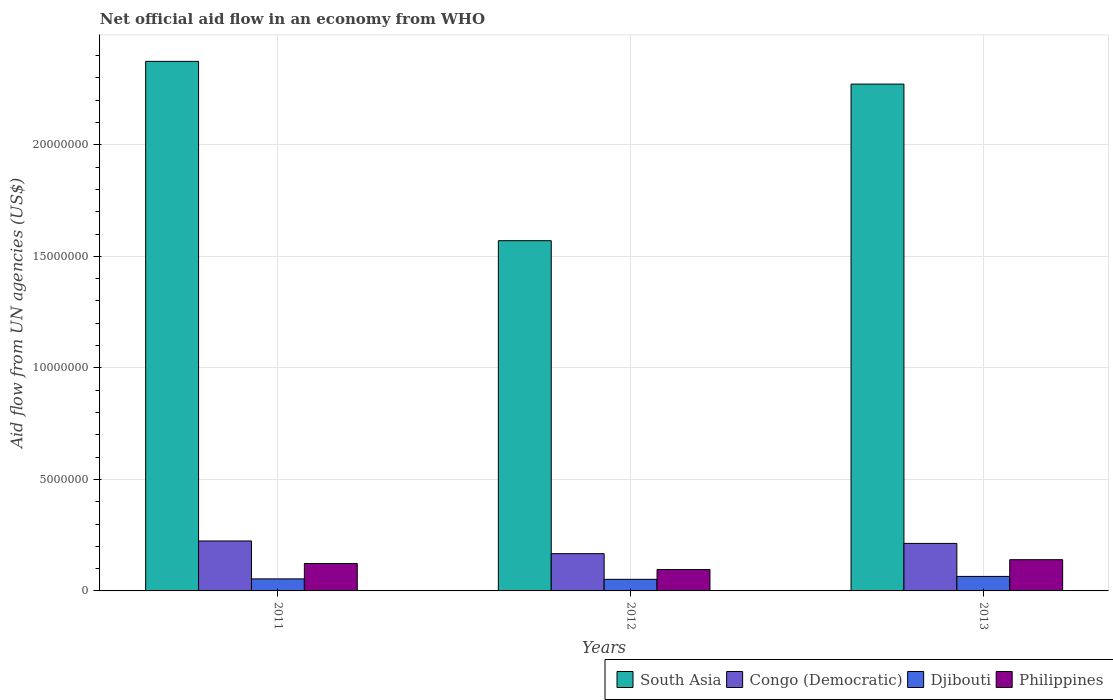How many different coloured bars are there?
Keep it short and to the point. 4. How many groups of bars are there?
Make the answer very short. 3. Are the number of bars on each tick of the X-axis equal?
Your answer should be compact. Yes. How many bars are there on the 2nd tick from the left?
Give a very brief answer. 4. How many bars are there on the 2nd tick from the right?
Keep it short and to the point. 4. In how many cases, is the number of bars for a given year not equal to the number of legend labels?
Your answer should be very brief. 0. What is the net official aid flow in South Asia in 2011?
Your answer should be compact. 2.37e+07. Across all years, what is the maximum net official aid flow in Philippines?
Offer a terse response. 1.40e+06. Across all years, what is the minimum net official aid flow in South Asia?
Your answer should be compact. 1.57e+07. What is the total net official aid flow in South Asia in the graph?
Provide a short and direct response. 6.22e+07. What is the difference between the net official aid flow in South Asia in 2011 and that in 2013?
Your answer should be compact. 1.02e+06. What is the difference between the net official aid flow in Djibouti in 2011 and the net official aid flow in South Asia in 2013?
Your response must be concise. -2.22e+07. What is the average net official aid flow in Philippines per year?
Your answer should be compact. 1.20e+06. In the year 2013, what is the difference between the net official aid flow in Philippines and net official aid flow in Congo (Democratic)?
Ensure brevity in your answer.  -7.30e+05. What is the ratio of the net official aid flow in Djibouti in 2011 to that in 2013?
Offer a very short reply. 0.83. Is the net official aid flow in Congo (Democratic) in 2012 less than that in 2013?
Make the answer very short. Yes. What is the difference between the highest and the lowest net official aid flow in South Asia?
Your answer should be compact. 8.04e+06. In how many years, is the net official aid flow in Djibouti greater than the average net official aid flow in Djibouti taken over all years?
Your answer should be very brief. 1. Is the sum of the net official aid flow in Philippines in 2012 and 2013 greater than the maximum net official aid flow in Congo (Democratic) across all years?
Offer a terse response. Yes. What does the 2nd bar from the left in 2013 represents?
Offer a very short reply. Congo (Democratic). How many bars are there?
Keep it short and to the point. 12. What is the difference between two consecutive major ticks on the Y-axis?
Offer a very short reply. 5.00e+06. Does the graph contain grids?
Provide a short and direct response. Yes. How many legend labels are there?
Your answer should be compact. 4. How are the legend labels stacked?
Provide a short and direct response. Horizontal. What is the title of the graph?
Your answer should be very brief. Net official aid flow in an economy from WHO. What is the label or title of the Y-axis?
Your answer should be very brief. Aid flow from UN agencies (US$). What is the Aid flow from UN agencies (US$) in South Asia in 2011?
Keep it short and to the point. 2.37e+07. What is the Aid flow from UN agencies (US$) of Congo (Democratic) in 2011?
Offer a very short reply. 2.24e+06. What is the Aid flow from UN agencies (US$) in Djibouti in 2011?
Your answer should be compact. 5.40e+05. What is the Aid flow from UN agencies (US$) in Philippines in 2011?
Your answer should be very brief. 1.23e+06. What is the Aid flow from UN agencies (US$) of South Asia in 2012?
Keep it short and to the point. 1.57e+07. What is the Aid flow from UN agencies (US$) of Congo (Democratic) in 2012?
Your answer should be very brief. 1.67e+06. What is the Aid flow from UN agencies (US$) of Djibouti in 2012?
Offer a very short reply. 5.20e+05. What is the Aid flow from UN agencies (US$) of Philippines in 2012?
Your response must be concise. 9.60e+05. What is the Aid flow from UN agencies (US$) of South Asia in 2013?
Make the answer very short. 2.27e+07. What is the Aid flow from UN agencies (US$) in Congo (Democratic) in 2013?
Give a very brief answer. 2.13e+06. What is the Aid flow from UN agencies (US$) in Djibouti in 2013?
Offer a terse response. 6.50e+05. What is the Aid flow from UN agencies (US$) in Philippines in 2013?
Give a very brief answer. 1.40e+06. Across all years, what is the maximum Aid flow from UN agencies (US$) of South Asia?
Give a very brief answer. 2.37e+07. Across all years, what is the maximum Aid flow from UN agencies (US$) of Congo (Democratic)?
Keep it short and to the point. 2.24e+06. Across all years, what is the maximum Aid flow from UN agencies (US$) of Djibouti?
Provide a short and direct response. 6.50e+05. Across all years, what is the maximum Aid flow from UN agencies (US$) of Philippines?
Offer a terse response. 1.40e+06. Across all years, what is the minimum Aid flow from UN agencies (US$) of South Asia?
Give a very brief answer. 1.57e+07. Across all years, what is the minimum Aid flow from UN agencies (US$) of Congo (Democratic)?
Offer a very short reply. 1.67e+06. Across all years, what is the minimum Aid flow from UN agencies (US$) in Djibouti?
Provide a short and direct response. 5.20e+05. Across all years, what is the minimum Aid flow from UN agencies (US$) in Philippines?
Your response must be concise. 9.60e+05. What is the total Aid flow from UN agencies (US$) in South Asia in the graph?
Provide a short and direct response. 6.22e+07. What is the total Aid flow from UN agencies (US$) of Congo (Democratic) in the graph?
Offer a terse response. 6.04e+06. What is the total Aid flow from UN agencies (US$) of Djibouti in the graph?
Provide a succinct answer. 1.71e+06. What is the total Aid flow from UN agencies (US$) in Philippines in the graph?
Offer a very short reply. 3.59e+06. What is the difference between the Aid flow from UN agencies (US$) of South Asia in 2011 and that in 2012?
Provide a succinct answer. 8.04e+06. What is the difference between the Aid flow from UN agencies (US$) in Congo (Democratic) in 2011 and that in 2012?
Offer a very short reply. 5.70e+05. What is the difference between the Aid flow from UN agencies (US$) of Djibouti in 2011 and that in 2012?
Your answer should be compact. 2.00e+04. What is the difference between the Aid flow from UN agencies (US$) of South Asia in 2011 and that in 2013?
Make the answer very short. 1.02e+06. What is the difference between the Aid flow from UN agencies (US$) in Congo (Democratic) in 2011 and that in 2013?
Ensure brevity in your answer.  1.10e+05. What is the difference between the Aid flow from UN agencies (US$) of Djibouti in 2011 and that in 2013?
Ensure brevity in your answer.  -1.10e+05. What is the difference between the Aid flow from UN agencies (US$) of South Asia in 2012 and that in 2013?
Ensure brevity in your answer.  -7.02e+06. What is the difference between the Aid flow from UN agencies (US$) in Congo (Democratic) in 2012 and that in 2013?
Provide a short and direct response. -4.60e+05. What is the difference between the Aid flow from UN agencies (US$) in Philippines in 2012 and that in 2013?
Offer a terse response. -4.40e+05. What is the difference between the Aid flow from UN agencies (US$) of South Asia in 2011 and the Aid flow from UN agencies (US$) of Congo (Democratic) in 2012?
Offer a very short reply. 2.21e+07. What is the difference between the Aid flow from UN agencies (US$) in South Asia in 2011 and the Aid flow from UN agencies (US$) in Djibouti in 2012?
Give a very brief answer. 2.32e+07. What is the difference between the Aid flow from UN agencies (US$) of South Asia in 2011 and the Aid flow from UN agencies (US$) of Philippines in 2012?
Your answer should be compact. 2.28e+07. What is the difference between the Aid flow from UN agencies (US$) in Congo (Democratic) in 2011 and the Aid flow from UN agencies (US$) in Djibouti in 2012?
Provide a succinct answer. 1.72e+06. What is the difference between the Aid flow from UN agencies (US$) of Congo (Democratic) in 2011 and the Aid flow from UN agencies (US$) of Philippines in 2012?
Make the answer very short. 1.28e+06. What is the difference between the Aid flow from UN agencies (US$) of Djibouti in 2011 and the Aid flow from UN agencies (US$) of Philippines in 2012?
Provide a succinct answer. -4.20e+05. What is the difference between the Aid flow from UN agencies (US$) in South Asia in 2011 and the Aid flow from UN agencies (US$) in Congo (Democratic) in 2013?
Give a very brief answer. 2.16e+07. What is the difference between the Aid flow from UN agencies (US$) in South Asia in 2011 and the Aid flow from UN agencies (US$) in Djibouti in 2013?
Offer a terse response. 2.31e+07. What is the difference between the Aid flow from UN agencies (US$) of South Asia in 2011 and the Aid flow from UN agencies (US$) of Philippines in 2013?
Provide a succinct answer. 2.23e+07. What is the difference between the Aid flow from UN agencies (US$) in Congo (Democratic) in 2011 and the Aid flow from UN agencies (US$) in Djibouti in 2013?
Your response must be concise. 1.59e+06. What is the difference between the Aid flow from UN agencies (US$) in Congo (Democratic) in 2011 and the Aid flow from UN agencies (US$) in Philippines in 2013?
Offer a terse response. 8.40e+05. What is the difference between the Aid flow from UN agencies (US$) of Djibouti in 2011 and the Aid flow from UN agencies (US$) of Philippines in 2013?
Offer a very short reply. -8.60e+05. What is the difference between the Aid flow from UN agencies (US$) in South Asia in 2012 and the Aid flow from UN agencies (US$) in Congo (Democratic) in 2013?
Make the answer very short. 1.36e+07. What is the difference between the Aid flow from UN agencies (US$) in South Asia in 2012 and the Aid flow from UN agencies (US$) in Djibouti in 2013?
Provide a succinct answer. 1.50e+07. What is the difference between the Aid flow from UN agencies (US$) of South Asia in 2012 and the Aid flow from UN agencies (US$) of Philippines in 2013?
Offer a very short reply. 1.43e+07. What is the difference between the Aid flow from UN agencies (US$) of Congo (Democratic) in 2012 and the Aid flow from UN agencies (US$) of Djibouti in 2013?
Offer a very short reply. 1.02e+06. What is the difference between the Aid flow from UN agencies (US$) in Congo (Democratic) in 2012 and the Aid flow from UN agencies (US$) in Philippines in 2013?
Keep it short and to the point. 2.70e+05. What is the difference between the Aid flow from UN agencies (US$) of Djibouti in 2012 and the Aid flow from UN agencies (US$) of Philippines in 2013?
Ensure brevity in your answer.  -8.80e+05. What is the average Aid flow from UN agencies (US$) in South Asia per year?
Ensure brevity in your answer.  2.07e+07. What is the average Aid flow from UN agencies (US$) of Congo (Democratic) per year?
Keep it short and to the point. 2.01e+06. What is the average Aid flow from UN agencies (US$) in Djibouti per year?
Offer a very short reply. 5.70e+05. What is the average Aid flow from UN agencies (US$) in Philippines per year?
Provide a succinct answer. 1.20e+06. In the year 2011, what is the difference between the Aid flow from UN agencies (US$) of South Asia and Aid flow from UN agencies (US$) of Congo (Democratic)?
Your response must be concise. 2.15e+07. In the year 2011, what is the difference between the Aid flow from UN agencies (US$) in South Asia and Aid flow from UN agencies (US$) in Djibouti?
Give a very brief answer. 2.32e+07. In the year 2011, what is the difference between the Aid flow from UN agencies (US$) of South Asia and Aid flow from UN agencies (US$) of Philippines?
Offer a terse response. 2.25e+07. In the year 2011, what is the difference between the Aid flow from UN agencies (US$) in Congo (Democratic) and Aid flow from UN agencies (US$) in Djibouti?
Your response must be concise. 1.70e+06. In the year 2011, what is the difference between the Aid flow from UN agencies (US$) of Congo (Democratic) and Aid flow from UN agencies (US$) of Philippines?
Provide a short and direct response. 1.01e+06. In the year 2011, what is the difference between the Aid flow from UN agencies (US$) of Djibouti and Aid flow from UN agencies (US$) of Philippines?
Provide a short and direct response. -6.90e+05. In the year 2012, what is the difference between the Aid flow from UN agencies (US$) in South Asia and Aid flow from UN agencies (US$) in Congo (Democratic)?
Provide a succinct answer. 1.40e+07. In the year 2012, what is the difference between the Aid flow from UN agencies (US$) of South Asia and Aid flow from UN agencies (US$) of Djibouti?
Offer a terse response. 1.52e+07. In the year 2012, what is the difference between the Aid flow from UN agencies (US$) of South Asia and Aid flow from UN agencies (US$) of Philippines?
Provide a short and direct response. 1.47e+07. In the year 2012, what is the difference between the Aid flow from UN agencies (US$) of Congo (Democratic) and Aid flow from UN agencies (US$) of Djibouti?
Give a very brief answer. 1.15e+06. In the year 2012, what is the difference between the Aid flow from UN agencies (US$) of Congo (Democratic) and Aid flow from UN agencies (US$) of Philippines?
Offer a terse response. 7.10e+05. In the year 2012, what is the difference between the Aid flow from UN agencies (US$) of Djibouti and Aid flow from UN agencies (US$) of Philippines?
Your answer should be very brief. -4.40e+05. In the year 2013, what is the difference between the Aid flow from UN agencies (US$) in South Asia and Aid flow from UN agencies (US$) in Congo (Democratic)?
Provide a short and direct response. 2.06e+07. In the year 2013, what is the difference between the Aid flow from UN agencies (US$) in South Asia and Aid flow from UN agencies (US$) in Djibouti?
Provide a short and direct response. 2.21e+07. In the year 2013, what is the difference between the Aid flow from UN agencies (US$) of South Asia and Aid flow from UN agencies (US$) of Philippines?
Your answer should be very brief. 2.13e+07. In the year 2013, what is the difference between the Aid flow from UN agencies (US$) in Congo (Democratic) and Aid flow from UN agencies (US$) in Djibouti?
Give a very brief answer. 1.48e+06. In the year 2013, what is the difference between the Aid flow from UN agencies (US$) of Congo (Democratic) and Aid flow from UN agencies (US$) of Philippines?
Your answer should be compact. 7.30e+05. In the year 2013, what is the difference between the Aid flow from UN agencies (US$) of Djibouti and Aid flow from UN agencies (US$) of Philippines?
Your answer should be compact. -7.50e+05. What is the ratio of the Aid flow from UN agencies (US$) of South Asia in 2011 to that in 2012?
Keep it short and to the point. 1.51. What is the ratio of the Aid flow from UN agencies (US$) in Congo (Democratic) in 2011 to that in 2012?
Give a very brief answer. 1.34. What is the ratio of the Aid flow from UN agencies (US$) of Djibouti in 2011 to that in 2012?
Ensure brevity in your answer.  1.04. What is the ratio of the Aid flow from UN agencies (US$) of Philippines in 2011 to that in 2012?
Give a very brief answer. 1.28. What is the ratio of the Aid flow from UN agencies (US$) in South Asia in 2011 to that in 2013?
Ensure brevity in your answer.  1.04. What is the ratio of the Aid flow from UN agencies (US$) in Congo (Democratic) in 2011 to that in 2013?
Your response must be concise. 1.05. What is the ratio of the Aid flow from UN agencies (US$) of Djibouti in 2011 to that in 2013?
Keep it short and to the point. 0.83. What is the ratio of the Aid flow from UN agencies (US$) of Philippines in 2011 to that in 2013?
Ensure brevity in your answer.  0.88. What is the ratio of the Aid flow from UN agencies (US$) of South Asia in 2012 to that in 2013?
Make the answer very short. 0.69. What is the ratio of the Aid flow from UN agencies (US$) in Congo (Democratic) in 2012 to that in 2013?
Your answer should be very brief. 0.78. What is the ratio of the Aid flow from UN agencies (US$) in Philippines in 2012 to that in 2013?
Give a very brief answer. 0.69. What is the difference between the highest and the second highest Aid flow from UN agencies (US$) of South Asia?
Provide a short and direct response. 1.02e+06. What is the difference between the highest and the second highest Aid flow from UN agencies (US$) in Congo (Democratic)?
Ensure brevity in your answer.  1.10e+05. What is the difference between the highest and the lowest Aid flow from UN agencies (US$) of South Asia?
Give a very brief answer. 8.04e+06. What is the difference between the highest and the lowest Aid flow from UN agencies (US$) of Congo (Democratic)?
Give a very brief answer. 5.70e+05. 